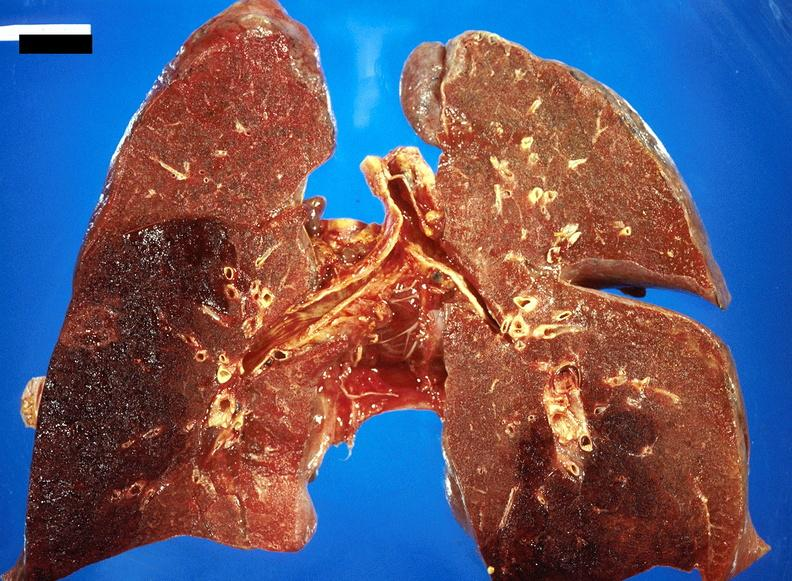how does this image show subacute pulmonary thromboembolus?
Answer the question using a single word or phrase. With acute infarct 